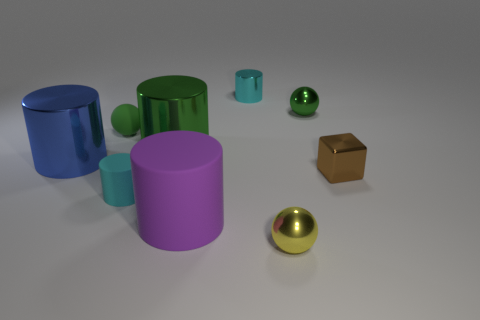Subtract all green cylinders. How many cylinders are left? 4 Subtract all green cylinders. How many cylinders are left? 4 Subtract 1 cylinders. How many cylinders are left? 4 Subtract all yellow cylinders. Subtract all red cubes. How many cylinders are left? 5 Subtract all blocks. How many objects are left? 8 Add 1 large metallic cylinders. How many large metallic cylinders exist? 3 Subtract 0 green cubes. How many objects are left? 9 Subtract all yellow cylinders. Subtract all green rubber spheres. How many objects are left? 8 Add 4 cyan metal cylinders. How many cyan metal cylinders are left? 5 